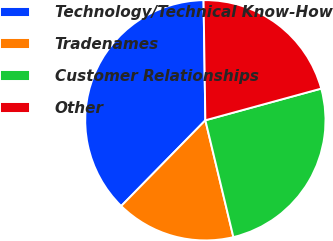Convert chart to OTSL. <chart><loc_0><loc_0><loc_500><loc_500><pie_chart><fcel>Technology/Technical Know-How<fcel>Tradenames<fcel>Customer Relationships<fcel>Other<nl><fcel>37.41%<fcel>16.1%<fcel>25.5%<fcel>20.99%<nl></chart> 